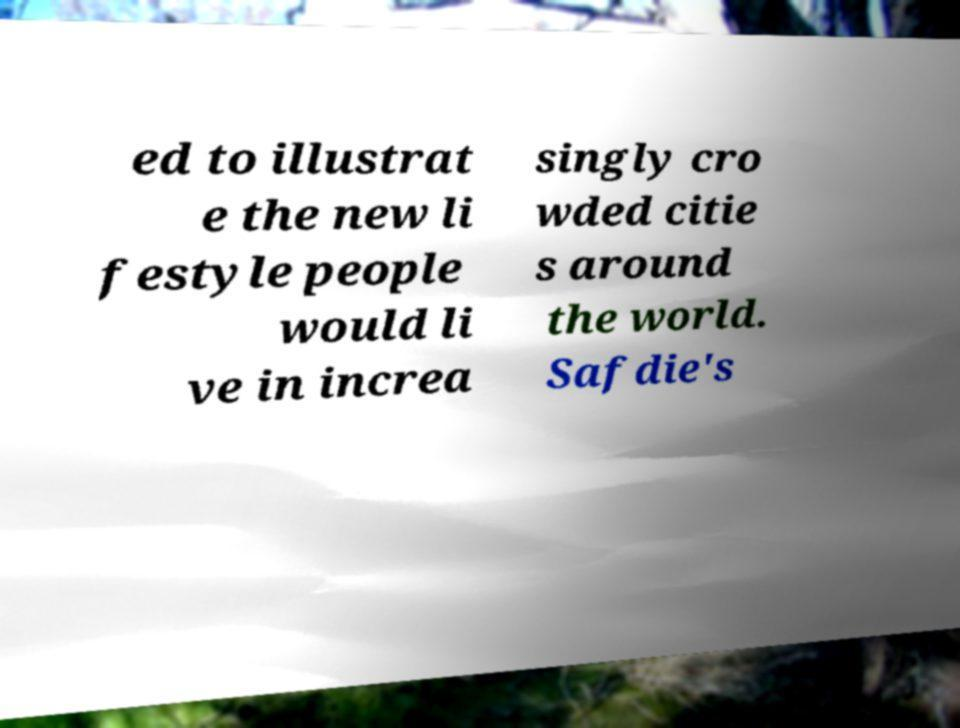Please read and relay the text visible in this image. What does it say? ed to illustrat e the new li festyle people would li ve in increa singly cro wded citie s around the world. Safdie's 